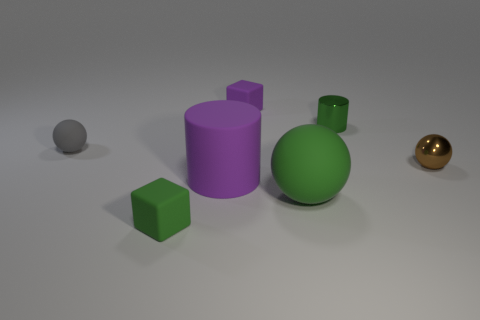Is there anything else that is the same color as the large cylinder?
Keep it short and to the point. Yes. What material is the tiny green object on the right side of the small cube in front of the cylinder in front of the tiny green cylinder?
Make the answer very short. Metal. Do the brown shiny object and the large purple object have the same shape?
Give a very brief answer. No. Is there anything else that has the same material as the big green sphere?
Provide a succinct answer. Yes. What number of tiny objects are both on the right side of the small green metallic thing and left of the brown sphere?
Your answer should be compact. 0. What color is the large thing that is right of the tiny rubber object that is behind the small cylinder?
Ensure brevity in your answer.  Green. Is the number of tiny brown balls left of the big purple cylinder the same as the number of gray rubber spheres?
Ensure brevity in your answer.  No. There is a matte object that is to the left of the small green thing that is on the left side of the big green rubber sphere; what number of small metal balls are to the right of it?
Give a very brief answer. 1. What color is the small sphere on the right side of the green sphere?
Keep it short and to the point. Brown. The green thing that is in front of the rubber cylinder and behind the tiny green matte object is made of what material?
Offer a terse response. Rubber. 